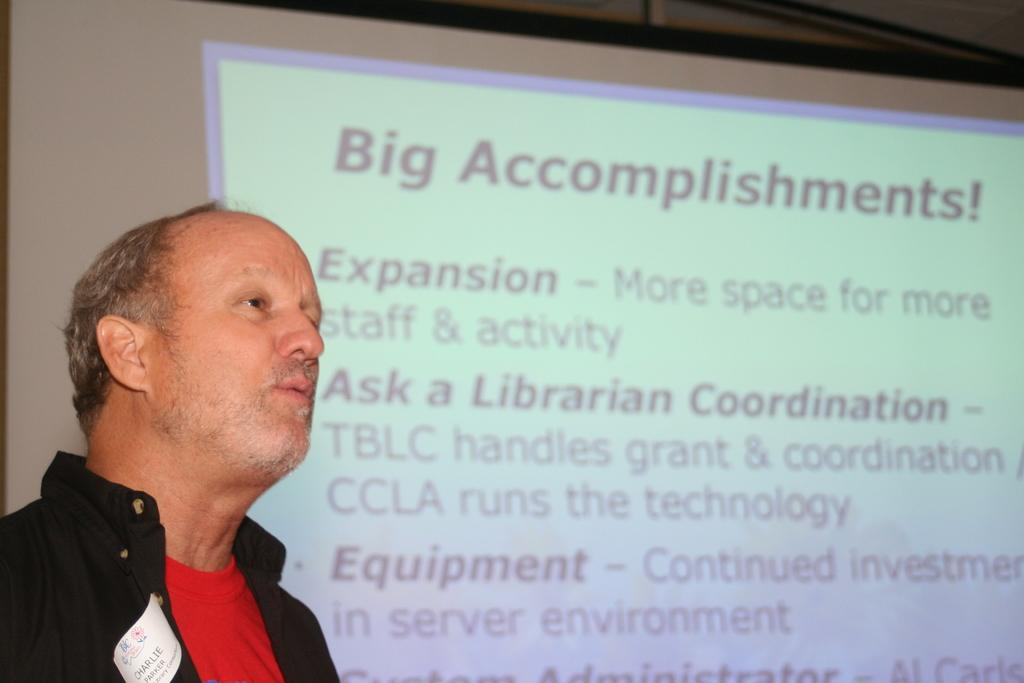What is the main subject of the image? There is a person in the image. Can you describe the background of the image? There is text on a screen behind the person. What type of body is visible on the desk in the image? There is no body or desk present in the image. 